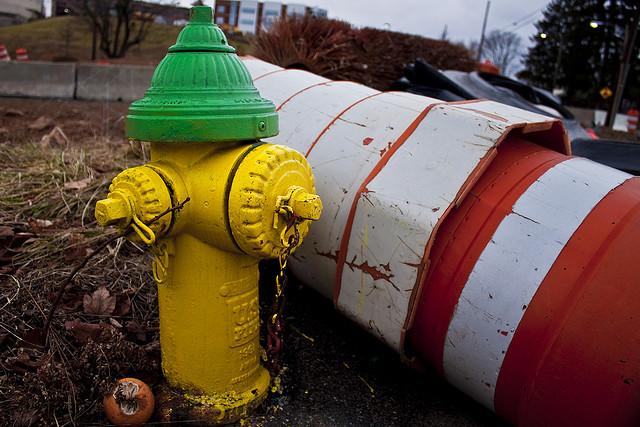Is the ground clean?
Give a very brief answer. No. What is laying next to the hydrant?
Give a very brief answer. Cones. What is the small orange item to the left of the hydrant?
Answer briefly. Orange. 